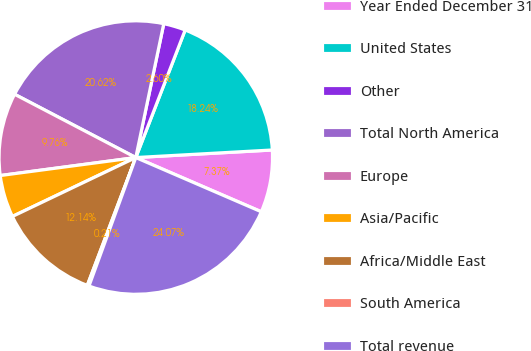Convert chart. <chart><loc_0><loc_0><loc_500><loc_500><pie_chart><fcel>Year Ended December 31<fcel>United States<fcel>Other<fcel>Total North America<fcel>Europe<fcel>Asia/Pacific<fcel>Africa/Middle East<fcel>South America<fcel>Total revenue<nl><fcel>7.37%<fcel>18.24%<fcel>2.6%<fcel>20.62%<fcel>9.76%<fcel>4.99%<fcel>12.14%<fcel>0.21%<fcel>24.07%<nl></chart> 